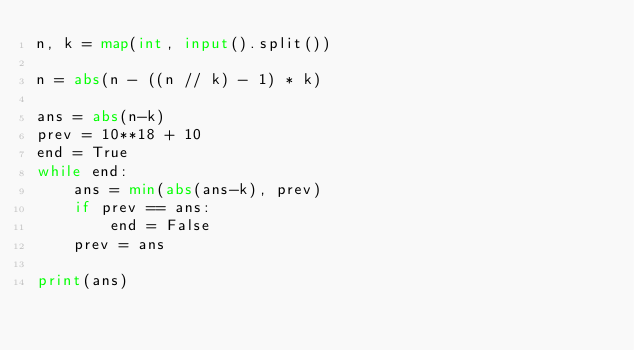Convert code to text. <code><loc_0><loc_0><loc_500><loc_500><_Python_>n, k = map(int, input().split())

n = abs(n - ((n // k) - 1) * k)

ans = abs(n-k)
prev = 10**18 + 10
end = True
while end:
    ans = min(abs(ans-k), prev)
    if prev == ans:
        end = False
    prev = ans

print(ans)</code> 